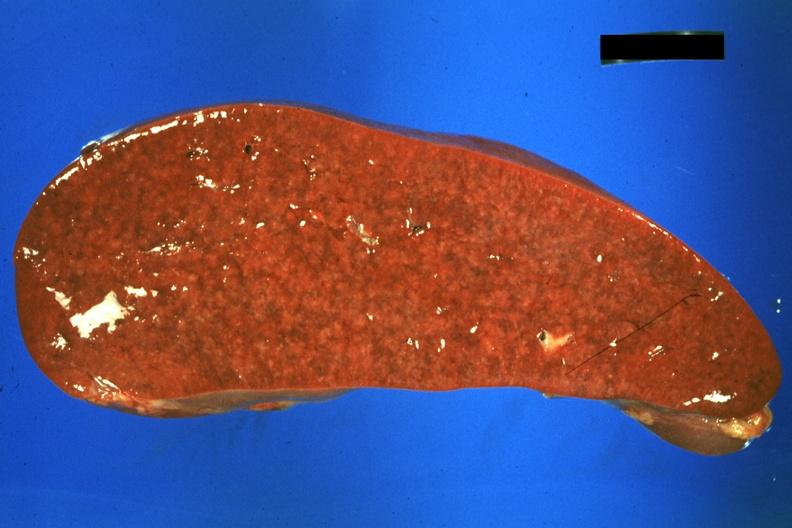s gangrene toe in infant present?
Answer the question using a single word or phrase. No 